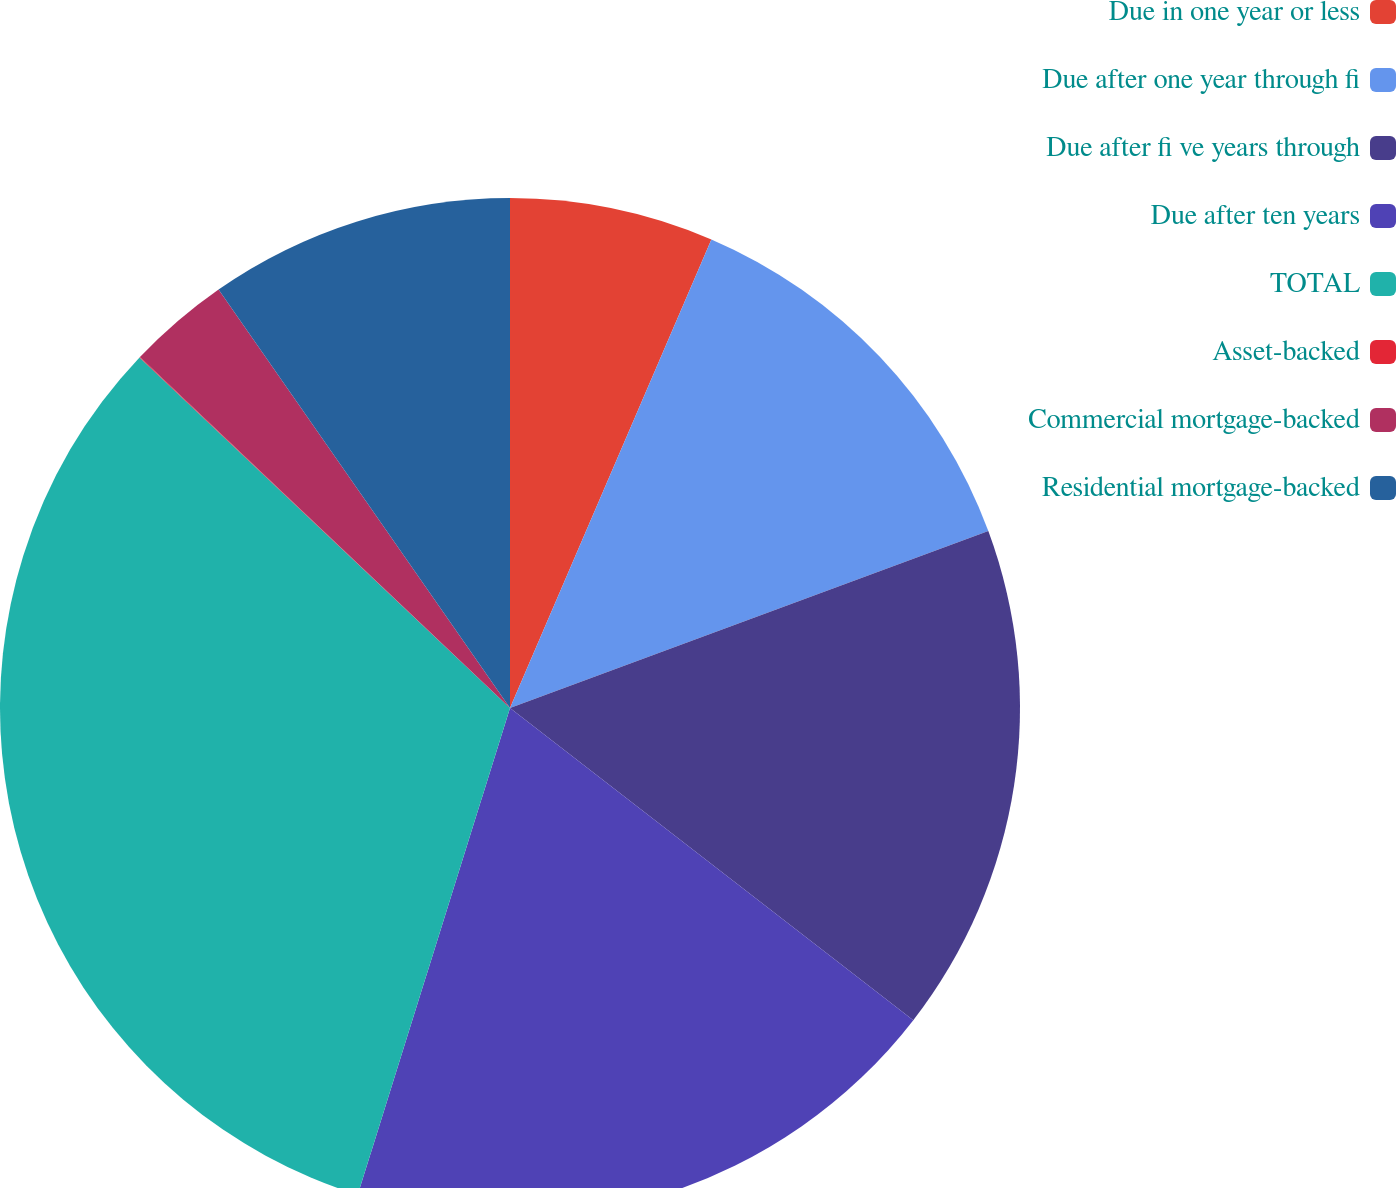Convert chart to OTSL. <chart><loc_0><loc_0><loc_500><loc_500><pie_chart><fcel>Due in one year or less<fcel>Due after one year through fi<fcel>Due after fi ve years through<fcel>Due after ten years<fcel>TOTAL<fcel>Asset-backed<fcel>Commercial mortgage-backed<fcel>Residential mortgage-backed<nl><fcel>6.46%<fcel>12.9%<fcel>16.12%<fcel>19.34%<fcel>32.23%<fcel>0.02%<fcel>3.24%<fcel>9.68%<nl></chart> 